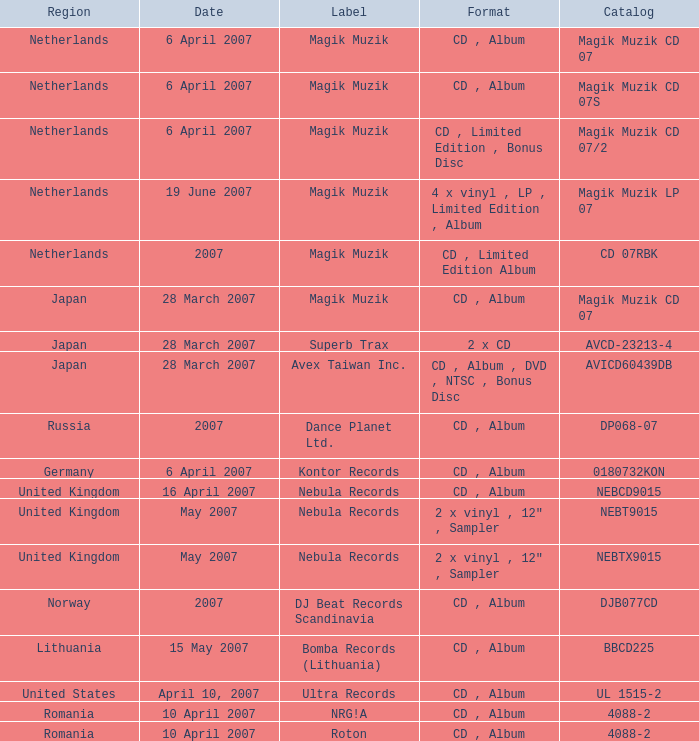What are the available formats for the catalog title dp068-07? CD , Album. 